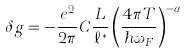<formula> <loc_0><loc_0><loc_500><loc_500>\delta g = - \frac { e ^ { 2 } } { 2 \pi } C \frac { L } { \ell ^ { * } } \left ( \frac { 4 \pi T } { \hbar { \omega } _ { F } } \right ) ^ { - \alpha _ { N } }</formula> 